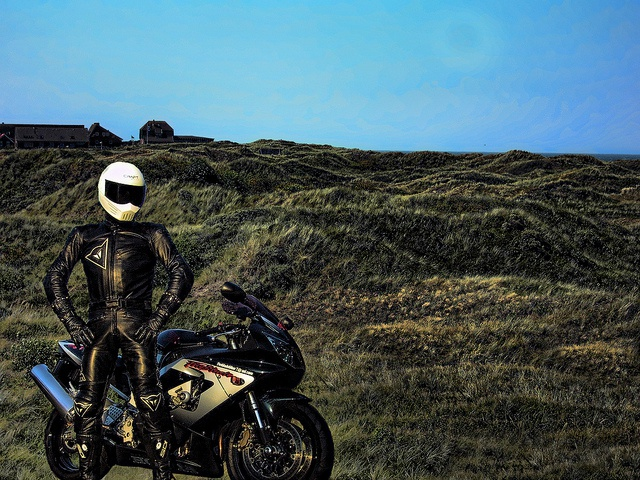Describe the objects in this image and their specific colors. I can see motorcycle in lightblue, black, gray, darkgreen, and tan tones and people in lightblue, black, gray, darkgreen, and ivory tones in this image. 